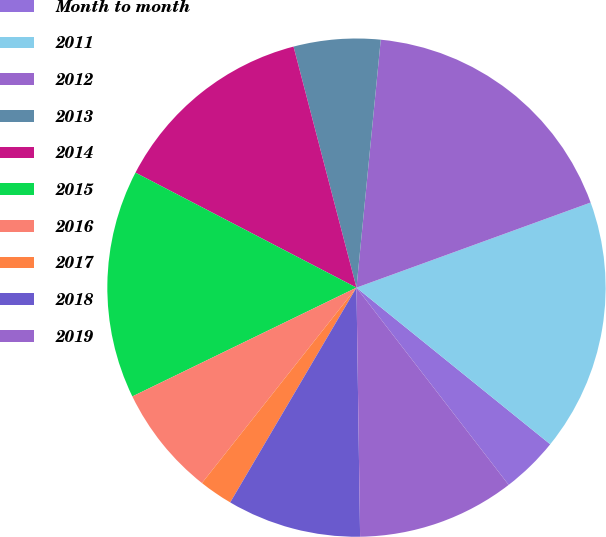Convert chart. <chart><loc_0><loc_0><loc_500><loc_500><pie_chart><fcel>Month to month<fcel>2011<fcel>2012<fcel>2013<fcel>2014<fcel>2015<fcel>2016<fcel>2017<fcel>2018<fcel>2019<nl><fcel>3.72%<fcel>16.37%<fcel>17.9%<fcel>5.62%<fcel>13.3%<fcel>14.83%<fcel>7.16%<fcel>2.19%<fcel>8.69%<fcel>10.23%<nl></chart> 